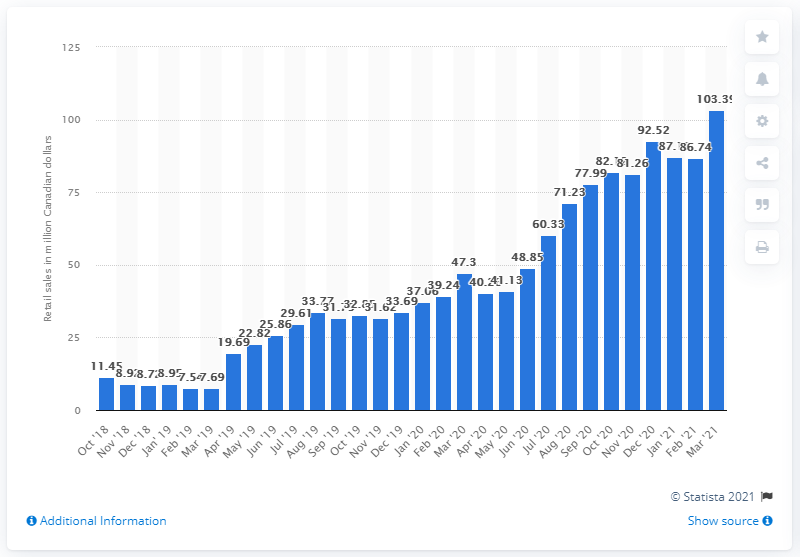Identify some key points in this picture. In March 2021, the monthly sales of cannabis in Ontario were 103.39 units. 